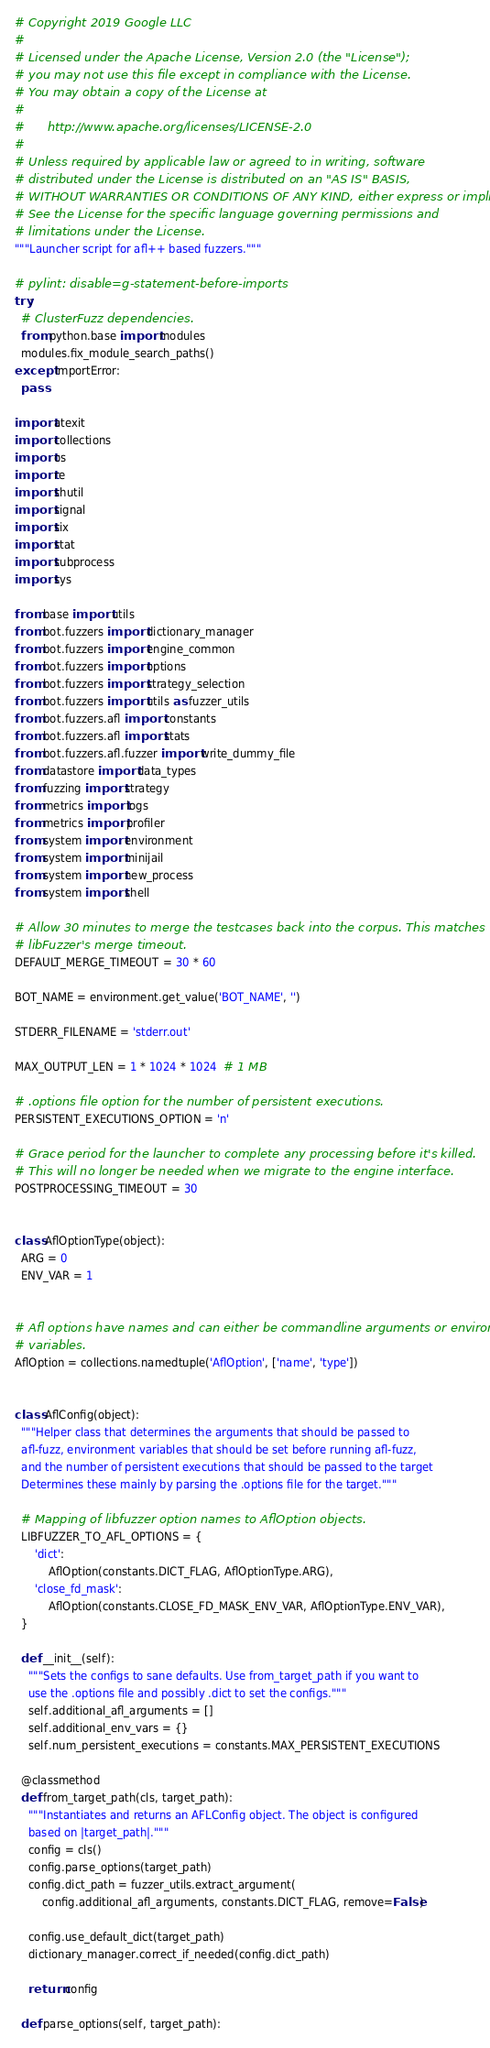<code> <loc_0><loc_0><loc_500><loc_500><_Python_># Copyright 2019 Google LLC
#
# Licensed under the Apache License, Version 2.0 (the "License");
# you may not use this file except in compliance with the License.
# You may obtain a copy of the License at
#
#      http://www.apache.org/licenses/LICENSE-2.0
#
# Unless required by applicable law or agreed to in writing, software
# distributed under the License is distributed on an "AS IS" BASIS,
# WITHOUT WARRANTIES OR CONDITIONS OF ANY KIND, either express or implied.
# See the License for the specific language governing permissions and
# limitations under the License.
"""Launcher script for afl++ based fuzzers."""

# pylint: disable=g-statement-before-imports
try:
  # ClusterFuzz dependencies.
  from python.base import modules
  modules.fix_module_search_paths()
except ImportError:
  pass

import atexit
import collections
import os
import re
import shutil
import signal
import six
import stat
import subprocess
import sys

from base import utils
from bot.fuzzers import dictionary_manager
from bot.fuzzers import engine_common
from bot.fuzzers import options
from bot.fuzzers import strategy_selection
from bot.fuzzers import utils as fuzzer_utils
from bot.fuzzers.afl import constants
from bot.fuzzers.afl import stats
from bot.fuzzers.afl.fuzzer import write_dummy_file
from datastore import data_types
from fuzzing import strategy
from metrics import logs
from metrics import profiler
from system import environment
from system import minijail
from system import new_process
from system import shell

# Allow 30 minutes to merge the testcases back into the corpus. This matches
# libFuzzer's merge timeout.
DEFAULT_MERGE_TIMEOUT = 30 * 60

BOT_NAME = environment.get_value('BOT_NAME', '')

STDERR_FILENAME = 'stderr.out'

MAX_OUTPUT_LEN = 1 * 1024 * 1024  # 1 MB

# .options file option for the number of persistent executions.
PERSISTENT_EXECUTIONS_OPTION = 'n'

# Grace period for the launcher to complete any processing before it's killed.
# This will no longer be needed when we migrate to the engine interface.
POSTPROCESSING_TIMEOUT = 30


class AflOptionType(object):
  ARG = 0
  ENV_VAR = 1


# Afl options have names and can either be commandline arguments or environment
# variables.
AflOption = collections.namedtuple('AflOption', ['name', 'type'])


class AflConfig(object):
  """Helper class that determines the arguments that should be passed to
  afl-fuzz, environment variables that should be set before running afl-fuzz,
  and the number of persistent executions that should be passed to the target
  Determines these mainly by parsing the .options file for the target."""

  # Mapping of libfuzzer option names to AflOption objects.
  LIBFUZZER_TO_AFL_OPTIONS = {
      'dict':
          AflOption(constants.DICT_FLAG, AflOptionType.ARG),
      'close_fd_mask':
          AflOption(constants.CLOSE_FD_MASK_ENV_VAR, AflOptionType.ENV_VAR),
  }

  def __init__(self):
    """Sets the configs to sane defaults. Use from_target_path if you want to
    use the .options file and possibly .dict to set the configs."""
    self.additional_afl_arguments = []
    self.additional_env_vars = {}
    self.num_persistent_executions = constants.MAX_PERSISTENT_EXECUTIONS

  @classmethod
  def from_target_path(cls, target_path):
    """Instantiates and returns an AFLConfig object. The object is configured
    based on |target_path|."""
    config = cls()
    config.parse_options(target_path)
    config.dict_path = fuzzer_utils.extract_argument(
        config.additional_afl_arguments, constants.DICT_FLAG, remove=False)

    config.use_default_dict(target_path)
    dictionary_manager.correct_if_needed(config.dict_path)

    return config

  def parse_options(self, target_path):</code> 